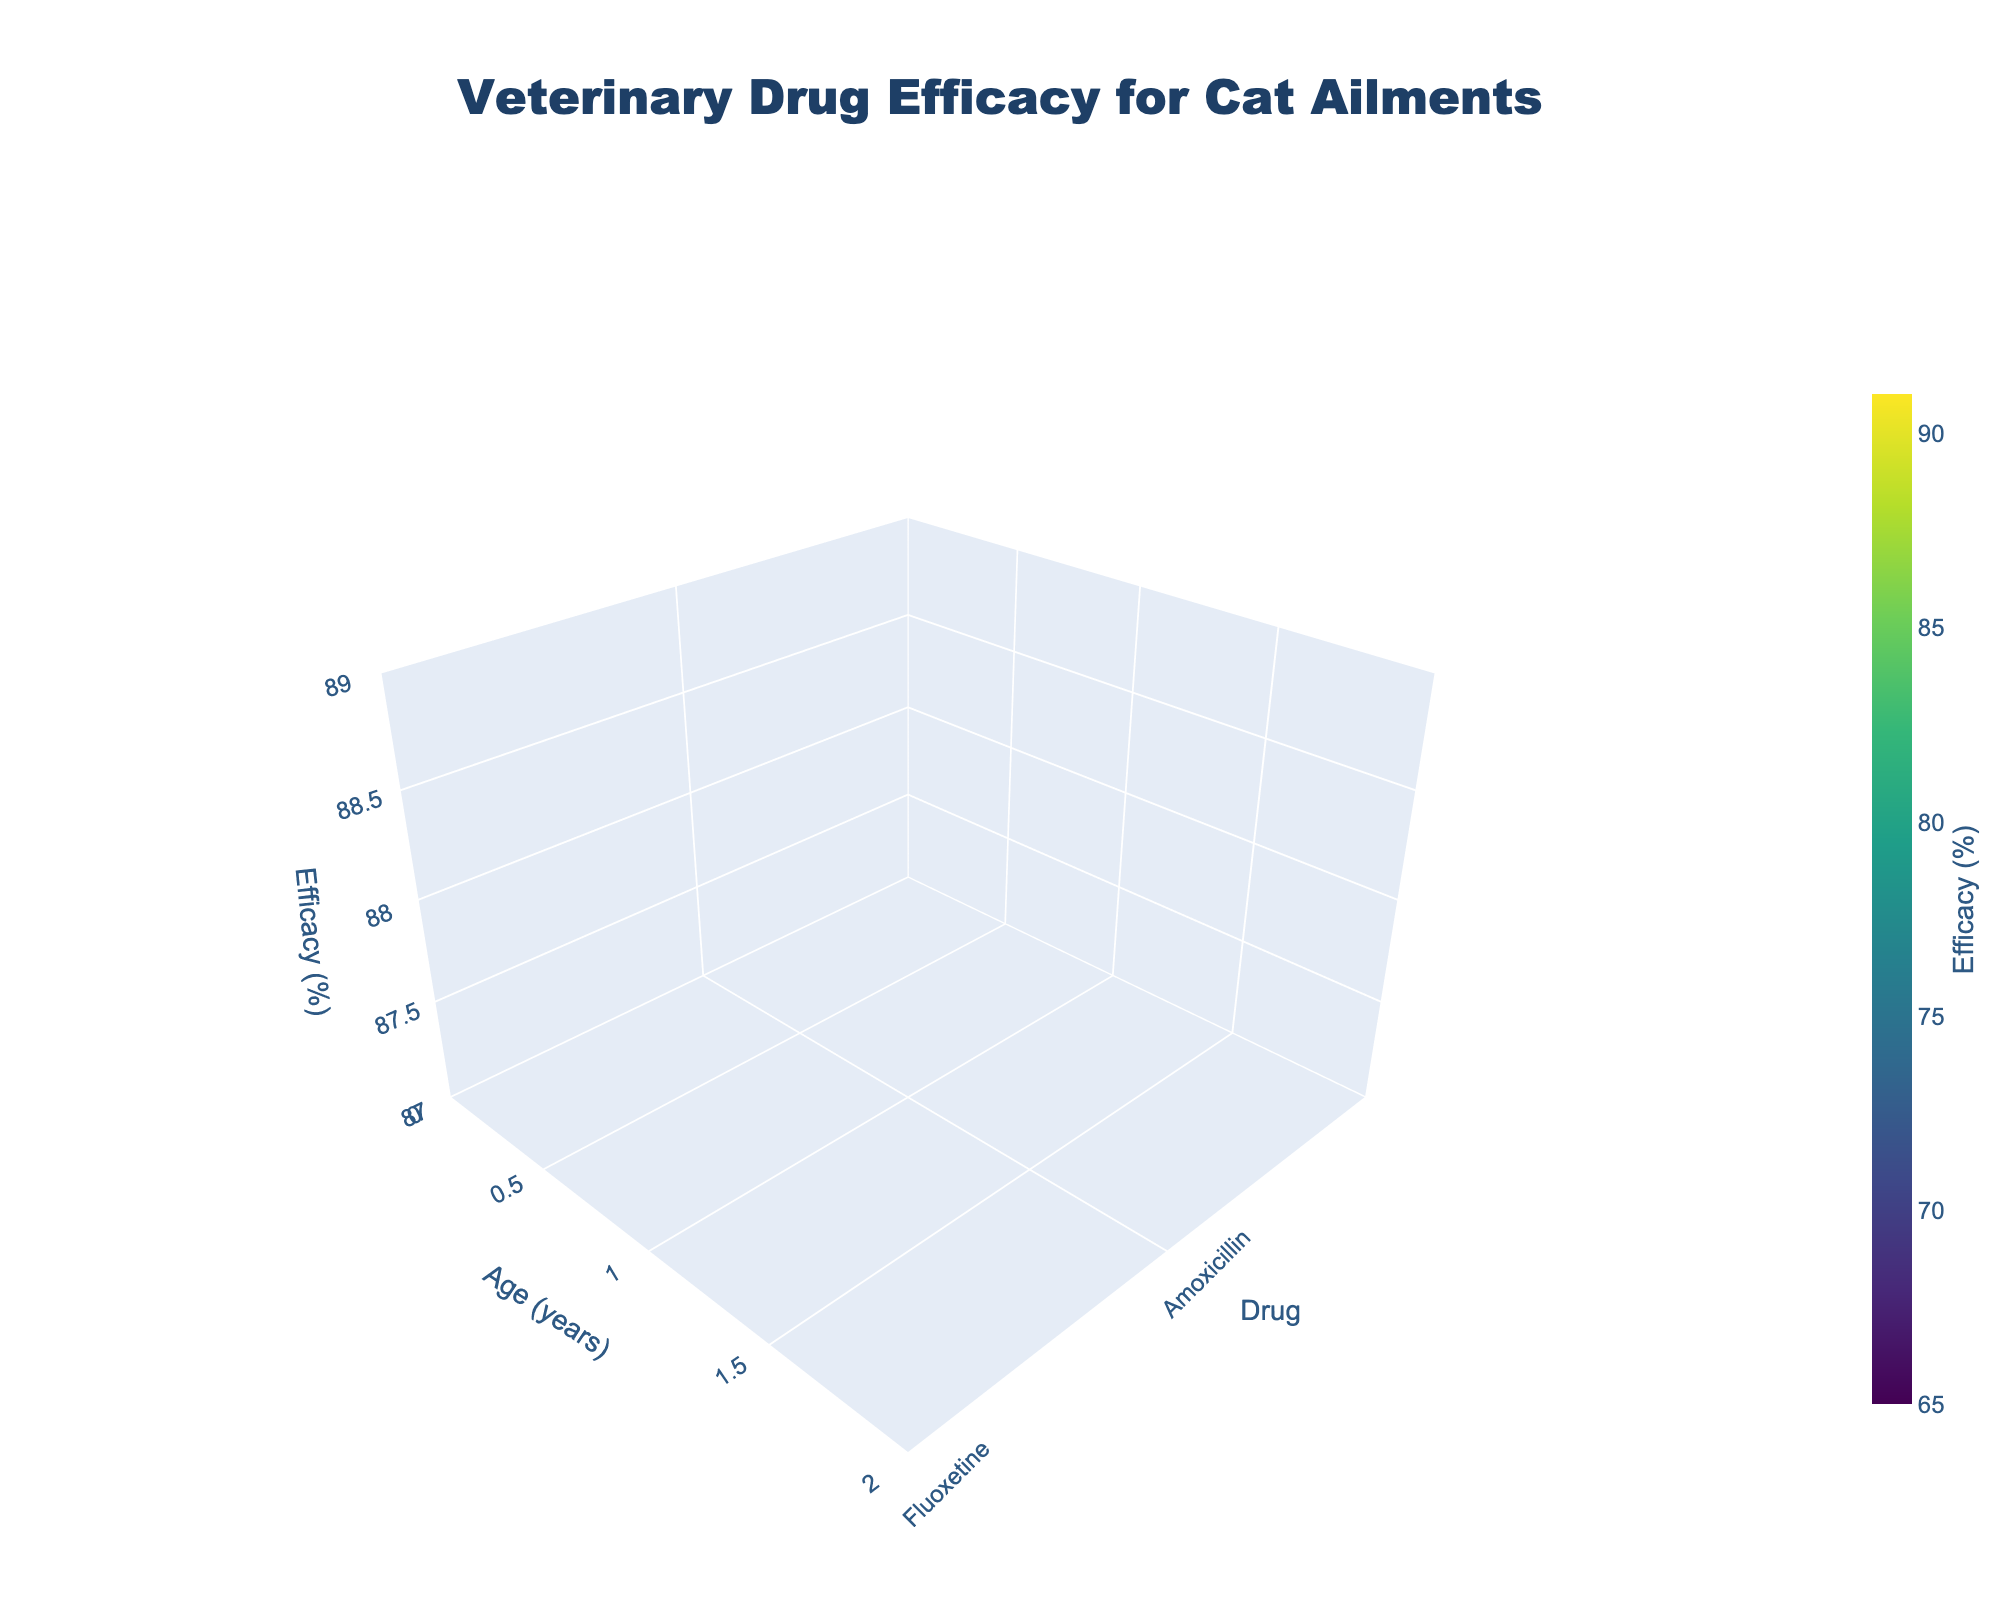What is the title of the graph? Look at the top center of the graph where the main title is located. The title reads "Veterinary Drug Efficacy for Cat Ailments."
Answer: Veterinary Drug Efficacy for Cat Ailments How is the Efficacy represented in terms of color? Observe the color scale on the plot, noting that efficacy levels change according to the colors represented by the Viridis colorscale. High efficacy is indicated by deeper colors, while lower efficacy levels are shown by lighter colors.
Answer: By the Viridis colorscale Which drug has the highest efficacy for Ragdolls? Locate Ragdolls along the age axis at 1 year old, and check the corresponding drug value along the efficacy axis. The highest value appears for Amoxicillin.
Answer: Amoxicillin Which age group shows the lowest efficacy for Fluoxetine? Identify the data points related to Fluoxetine across different ages. The lowest efficacy appears for the 15-year-old age group.
Answer: 15 years Which drug has the most consistent efficacy across all age groups? Review the surface plot to see which drug's efficacy values vary the least across different ages. Prednisolone appears to have the least variation in efficacy.
Answer: Prednisolone What is the average efficacy of Meloxicam across the visible age groups? Locate the efficacy values of Meloxicam at each age: 75 (2 years), 82 (8 years), and 68 (14 years). Sum these values and divide by the number of data points (3): (75 + 82 + 68)/3.
Answer: 75% How does the efficacy of Onsior for Burmese compare to that for Exotic Shorthair? Find the data points for Burmese (5 years old) and Exotic Shorthair (11 years old). Compare their efficacy values: Burmese has 86%, and Exotic Shorthair has 78%. Burmese has a higher efficacy.
Answer: Burmese is higher Which combination of drug and breed shows the highest efficacy? Scan through the plot to find the highest efficacy point and note the corresponding drug and breed. Amoxicillin for Russian Blue (91%) is the highest.
Answer: Amoxicillin for Russian Blue What is the range of efficacy values for Fluoxetine? Identify the minimum and maximum efficacy values for Fluoxetine across the age groups. Values are 65% (15 years) and 79% (9 years). The range is calculated as 79% - 65%.
Answer: 14% Which three drugs have the highest efficacy for cats under three years old? Look at the efficacy values for cats under three years for each drug: 
1. Amoxicillin (Ragdoll) - 88%,
2. Meloxicam (Siamese) - 75%,
3. Prednisolone (Abyssinian) - 84%.
Rank them.
Answer: Amoxicillin, Prednisolone, Meloxicam 